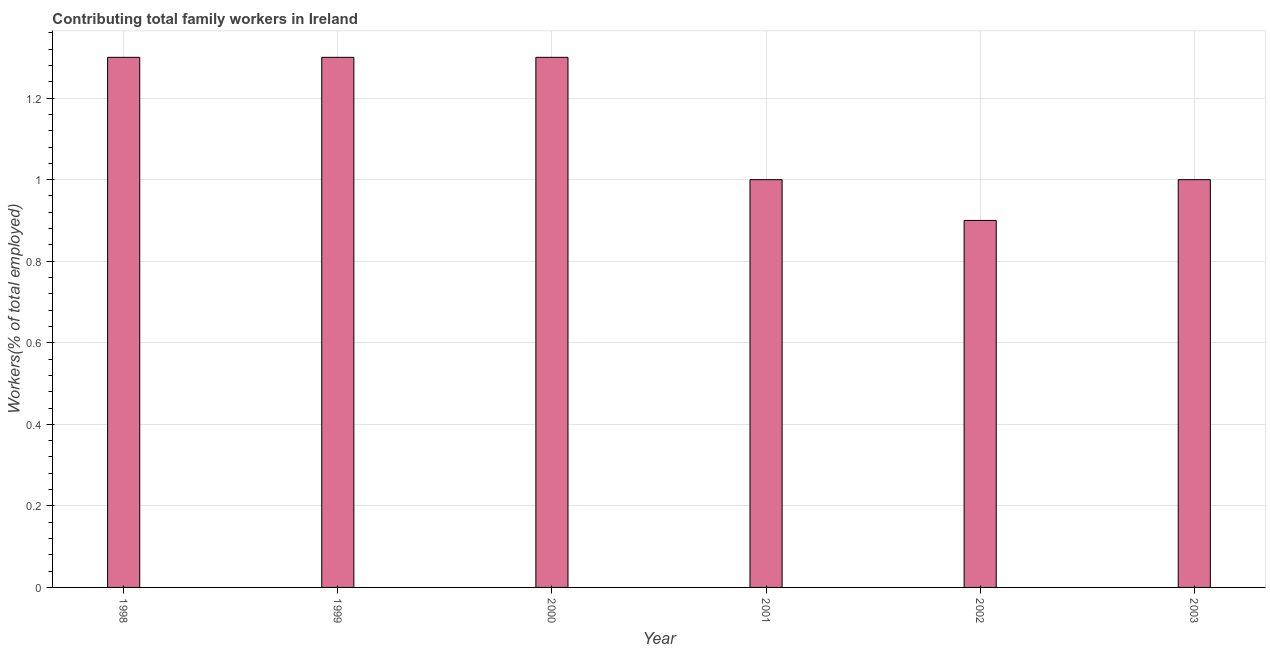Does the graph contain any zero values?
Ensure brevity in your answer.  No. Does the graph contain grids?
Ensure brevity in your answer.  Yes. What is the title of the graph?
Keep it short and to the point. Contributing total family workers in Ireland. What is the label or title of the X-axis?
Make the answer very short. Year. What is the label or title of the Y-axis?
Provide a short and direct response. Workers(% of total employed). What is the contributing family workers in 1998?
Ensure brevity in your answer.  1.3. Across all years, what is the maximum contributing family workers?
Provide a short and direct response. 1.3. Across all years, what is the minimum contributing family workers?
Provide a short and direct response. 0.9. In which year was the contributing family workers minimum?
Keep it short and to the point. 2002. What is the sum of the contributing family workers?
Your response must be concise. 6.8. What is the average contributing family workers per year?
Your answer should be very brief. 1.13. What is the median contributing family workers?
Provide a succinct answer. 1.15. In how many years, is the contributing family workers greater than 1.08 %?
Offer a terse response. 3. Do a majority of the years between 2002 and 2003 (inclusive) have contributing family workers greater than 0.56 %?
Ensure brevity in your answer.  Yes. What is the ratio of the contributing family workers in 1999 to that in 2002?
Your answer should be very brief. 1.44. Is the difference between the contributing family workers in 2001 and 2002 greater than the difference between any two years?
Provide a succinct answer. No. What is the difference between the highest and the lowest contributing family workers?
Offer a terse response. 0.4. In how many years, is the contributing family workers greater than the average contributing family workers taken over all years?
Your response must be concise. 3. How many bars are there?
Your answer should be very brief. 6. How many years are there in the graph?
Your answer should be compact. 6. Are the values on the major ticks of Y-axis written in scientific E-notation?
Give a very brief answer. No. What is the Workers(% of total employed) of 1998?
Provide a short and direct response. 1.3. What is the Workers(% of total employed) of 1999?
Ensure brevity in your answer.  1.3. What is the Workers(% of total employed) of 2000?
Your response must be concise. 1.3. What is the Workers(% of total employed) of 2002?
Give a very brief answer. 0.9. What is the difference between the Workers(% of total employed) in 1998 and 2001?
Give a very brief answer. 0.3. What is the difference between the Workers(% of total employed) in 1998 and 2002?
Your answer should be very brief. 0.4. What is the difference between the Workers(% of total employed) in 1999 and 2000?
Your answer should be compact. 0. What is the difference between the Workers(% of total employed) in 1999 and 2001?
Offer a very short reply. 0.3. What is the difference between the Workers(% of total employed) in 1999 and 2002?
Give a very brief answer. 0.4. What is the difference between the Workers(% of total employed) in 2000 and 2001?
Offer a terse response. 0.3. What is the difference between the Workers(% of total employed) in 2000 and 2003?
Keep it short and to the point. 0.3. What is the difference between the Workers(% of total employed) in 2001 and 2002?
Offer a very short reply. 0.1. What is the difference between the Workers(% of total employed) in 2002 and 2003?
Your answer should be compact. -0.1. What is the ratio of the Workers(% of total employed) in 1998 to that in 2000?
Your answer should be very brief. 1. What is the ratio of the Workers(% of total employed) in 1998 to that in 2001?
Your response must be concise. 1.3. What is the ratio of the Workers(% of total employed) in 1998 to that in 2002?
Ensure brevity in your answer.  1.44. What is the ratio of the Workers(% of total employed) in 1999 to that in 2002?
Provide a short and direct response. 1.44. What is the ratio of the Workers(% of total employed) in 2000 to that in 2001?
Make the answer very short. 1.3. What is the ratio of the Workers(% of total employed) in 2000 to that in 2002?
Offer a terse response. 1.44. What is the ratio of the Workers(% of total employed) in 2001 to that in 2002?
Offer a terse response. 1.11. What is the ratio of the Workers(% of total employed) in 2002 to that in 2003?
Give a very brief answer. 0.9. 